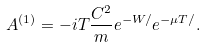Convert formula to latex. <formula><loc_0><loc_0><loc_500><loc_500>A ^ { ( 1 ) } = - i T \frac { C ^ { 2 } } m e ^ { - W / } e ^ { - \mu T / } .</formula> 